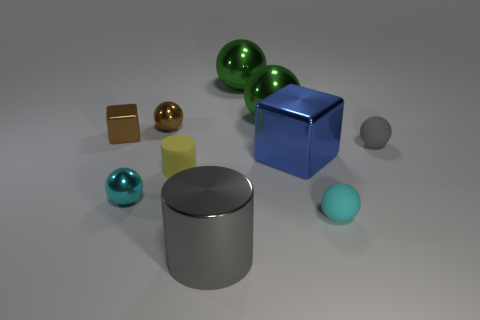What might the different sizes and colors of these objects suggest? The varied sizes could imply a comparative display, perhaps to showcase scale or to create visual interest through contrast. Colors often carry symbolic meaning or could be used to categorize objects. In this image, the diverse colors might suggest a spectrum or be part of an aesthetic choice to make the scene more vibrant and engaging. 